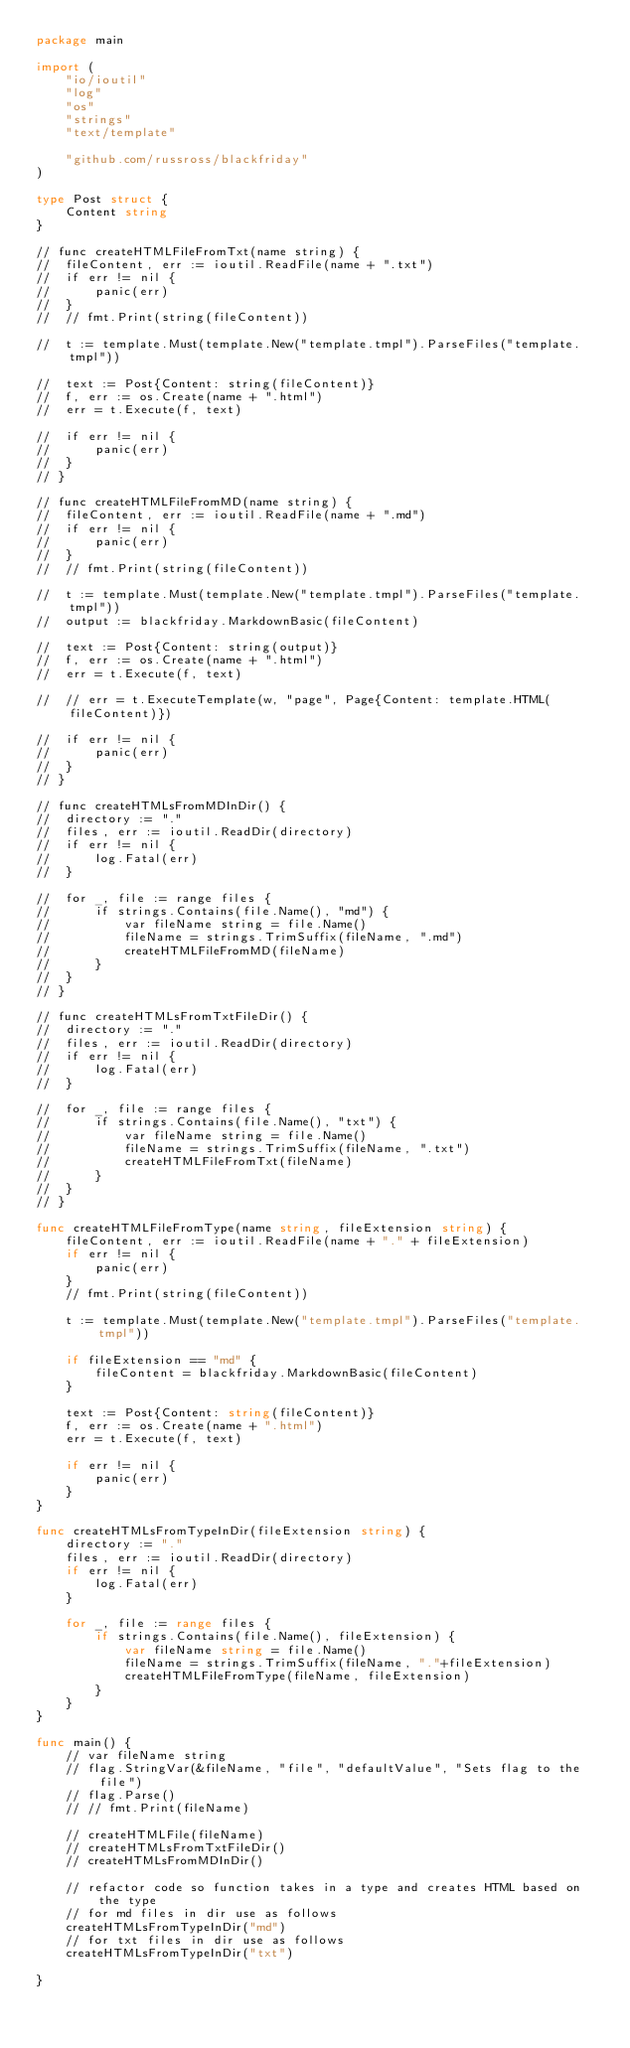Convert code to text. <code><loc_0><loc_0><loc_500><loc_500><_Go_>package main

import (
	"io/ioutil"
	"log"
	"os"
	"strings"
	"text/template"

	"github.com/russross/blackfriday"
)

type Post struct {
	Content string
}

// func createHTMLFileFromTxt(name string) {
// 	fileContent, err := ioutil.ReadFile(name + ".txt")
// 	if err != nil {
// 		panic(err)
// 	}
// 	// fmt.Print(string(fileContent))

// 	t := template.Must(template.New("template.tmpl").ParseFiles("template.tmpl"))

// 	text := Post{Content: string(fileContent)}
// 	f, err := os.Create(name + ".html")
// 	err = t.Execute(f, text)

// 	if err != nil {
// 		panic(err)
// 	}
// }

// func createHTMLFileFromMD(name string) {
// 	fileContent, err := ioutil.ReadFile(name + ".md")
// 	if err != nil {
// 		panic(err)
// 	}
// 	// fmt.Print(string(fileContent))

// 	t := template.Must(template.New("template.tmpl").ParseFiles("template.tmpl"))
// 	output := blackfriday.MarkdownBasic(fileContent)

// 	text := Post{Content: string(output)}
// 	f, err := os.Create(name + ".html")
// 	err = t.Execute(f, text)

// 	// err = t.ExecuteTemplate(w, "page", Page{Content: template.HTML(fileContent)})

// 	if err != nil {
// 		panic(err)
// 	}
// }

// func createHTMLsFromMDInDir() {
// 	directory := "."
// 	files, err := ioutil.ReadDir(directory)
// 	if err != nil {
// 		log.Fatal(err)
// 	}

// 	for _, file := range files {
// 		if strings.Contains(file.Name(), "md") {
// 			var fileName string = file.Name()
// 			fileName = strings.TrimSuffix(fileName, ".md")
// 			createHTMLFileFromMD(fileName)
// 		}
// 	}
// }

// func createHTMLsFromTxtFileDir() {
// 	directory := "."
// 	files, err := ioutil.ReadDir(directory)
// 	if err != nil {
// 		log.Fatal(err)
// 	}

// 	for _, file := range files {
// 		if strings.Contains(file.Name(), "txt") {
// 			var fileName string = file.Name()
// 			fileName = strings.TrimSuffix(fileName, ".txt")
// 			createHTMLFileFromTxt(fileName)
// 		}
// 	}
// }

func createHTMLFileFromType(name string, fileExtension string) {
	fileContent, err := ioutil.ReadFile(name + "." + fileExtension)
	if err != nil {
		panic(err)
	}
	// fmt.Print(string(fileContent))

	t := template.Must(template.New("template.tmpl").ParseFiles("template.tmpl"))

	if fileExtension == "md" {
		fileContent = blackfriday.MarkdownBasic(fileContent)
	}

	text := Post{Content: string(fileContent)}
	f, err := os.Create(name + ".html")
	err = t.Execute(f, text)

	if err != nil {
		panic(err)
	}
}

func createHTMLsFromTypeInDir(fileExtension string) {
	directory := "."
	files, err := ioutil.ReadDir(directory)
	if err != nil {
		log.Fatal(err)
	}

	for _, file := range files {
		if strings.Contains(file.Name(), fileExtension) {
			var fileName string = file.Name()
			fileName = strings.TrimSuffix(fileName, "."+fileExtension)
			createHTMLFileFromType(fileName, fileExtension)
		}
	}
}

func main() {
	// var fileName string
	// flag.StringVar(&fileName, "file", "defaultValue", "Sets flag to the file")
	// flag.Parse()
	// // fmt.Print(fileName)

	// createHTMLFile(fileName)
	// createHTMLsFromTxtFileDir()
	// createHTMLsFromMDInDir()

	// refactor code so function takes in a type and creates HTML based on the type
	// for md files in dir use as follows
	createHTMLsFromTypeInDir("md")
	// for txt files in dir use as follows
	createHTMLsFromTypeInDir("txt")

}
</code> 